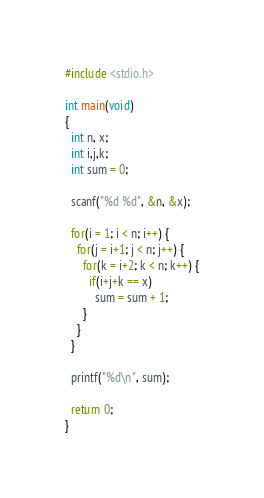Convert code to text. <code><loc_0><loc_0><loc_500><loc_500><_C_>#include <stdio.h>

int main(void)
{
  int n, x;
  int i,j,k;
  int sum = 0;

  scanf("%d %d", &n, &x);

  for(i = 1; i < n; i++) {
    for(j = i+1; j < n; j++) {
      for(k = i+2; k < n; k++) {
        if(i+j+k == x)
          sum = sum + 1;
      }
    }
  }

  printf("%d\n", sum);

  return 0;
}</code> 